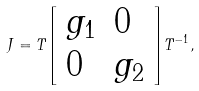<formula> <loc_0><loc_0><loc_500><loc_500>J = T { \left [ \begin{array} { l l } { g _ { 1 } } & { 0 } \\ { 0 } & { g _ { 2 } } \end{array} \right ] } T ^ { - 1 } ,</formula> 